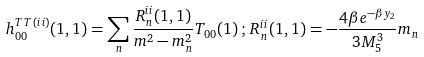<formula> <loc_0><loc_0><loc_500><loc_500>h _ { 0 0 } ^ { T T \, ( i i ) } ( 1 , 1 ) = \sum _ { n } \frac { R _ { n } ^ { i i } ( 1 , 1 ) } { m ^ { 2 } - m _ { n } ^ { 2 } } T _ { 0 0 } ( 1 ) \, ; \, R _ { n } ^ { i i } ( 1 , 1 ) = - \frac { 4 \beta e ^ { - \beta y _ { 2 } } } { 3 M _ { 5 } ^ { 3 } } m _ { n }</formula> 